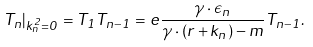<formula> <loc_0><loc_0><loc_500><loc_500>T _ { n } | _ { k _ { n } ^ { 2 } = 0 } = T _ { 1 } T _ { n - 1 } = e \frac { \gamma \cdot \epsilon _ { n } } { \gamma \cdot ( r + k _ { n } ) - m } T _ { n - 1 } .</formula> 